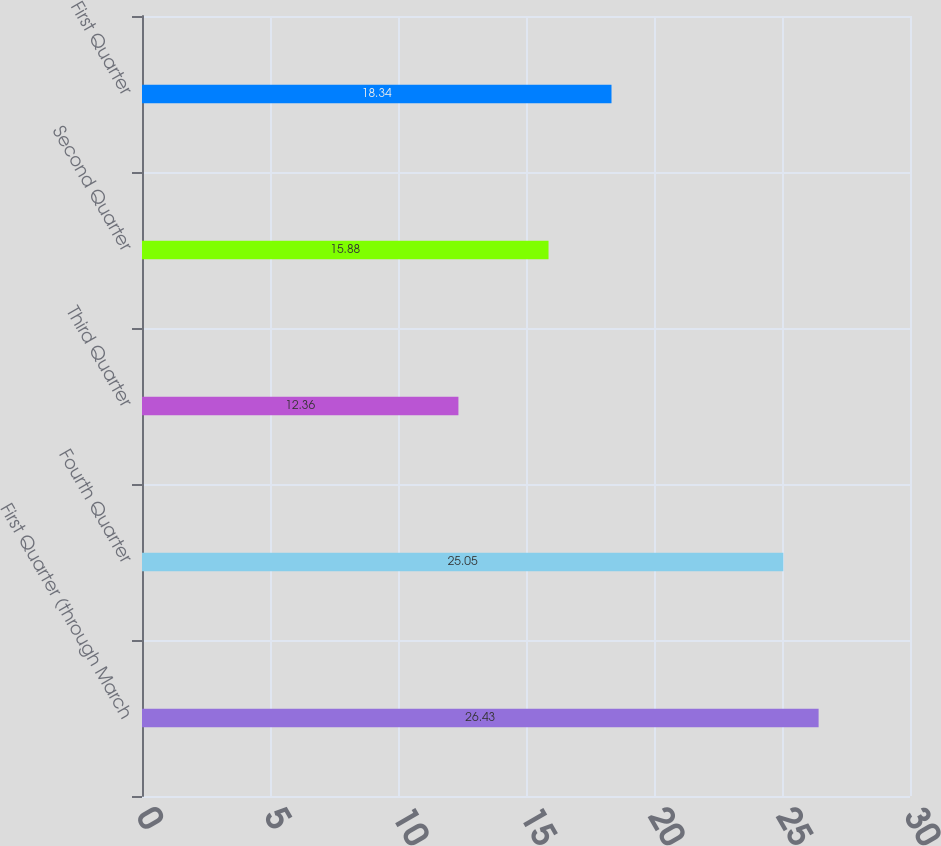Convert chart to OTSL. <chart><loc_0><loc_0><loc_500><loc_500><bar_chart><fcel>First Quarter (through March<fcel>Fourth Quarter<fcel>Third Quarter<fcel>Second Quarter<fcel>First Quarter<nl><fcel>26.43<fcel>25.05<fcel>12.36<fcel>15.88<fcel>18.34<nl></chart> 